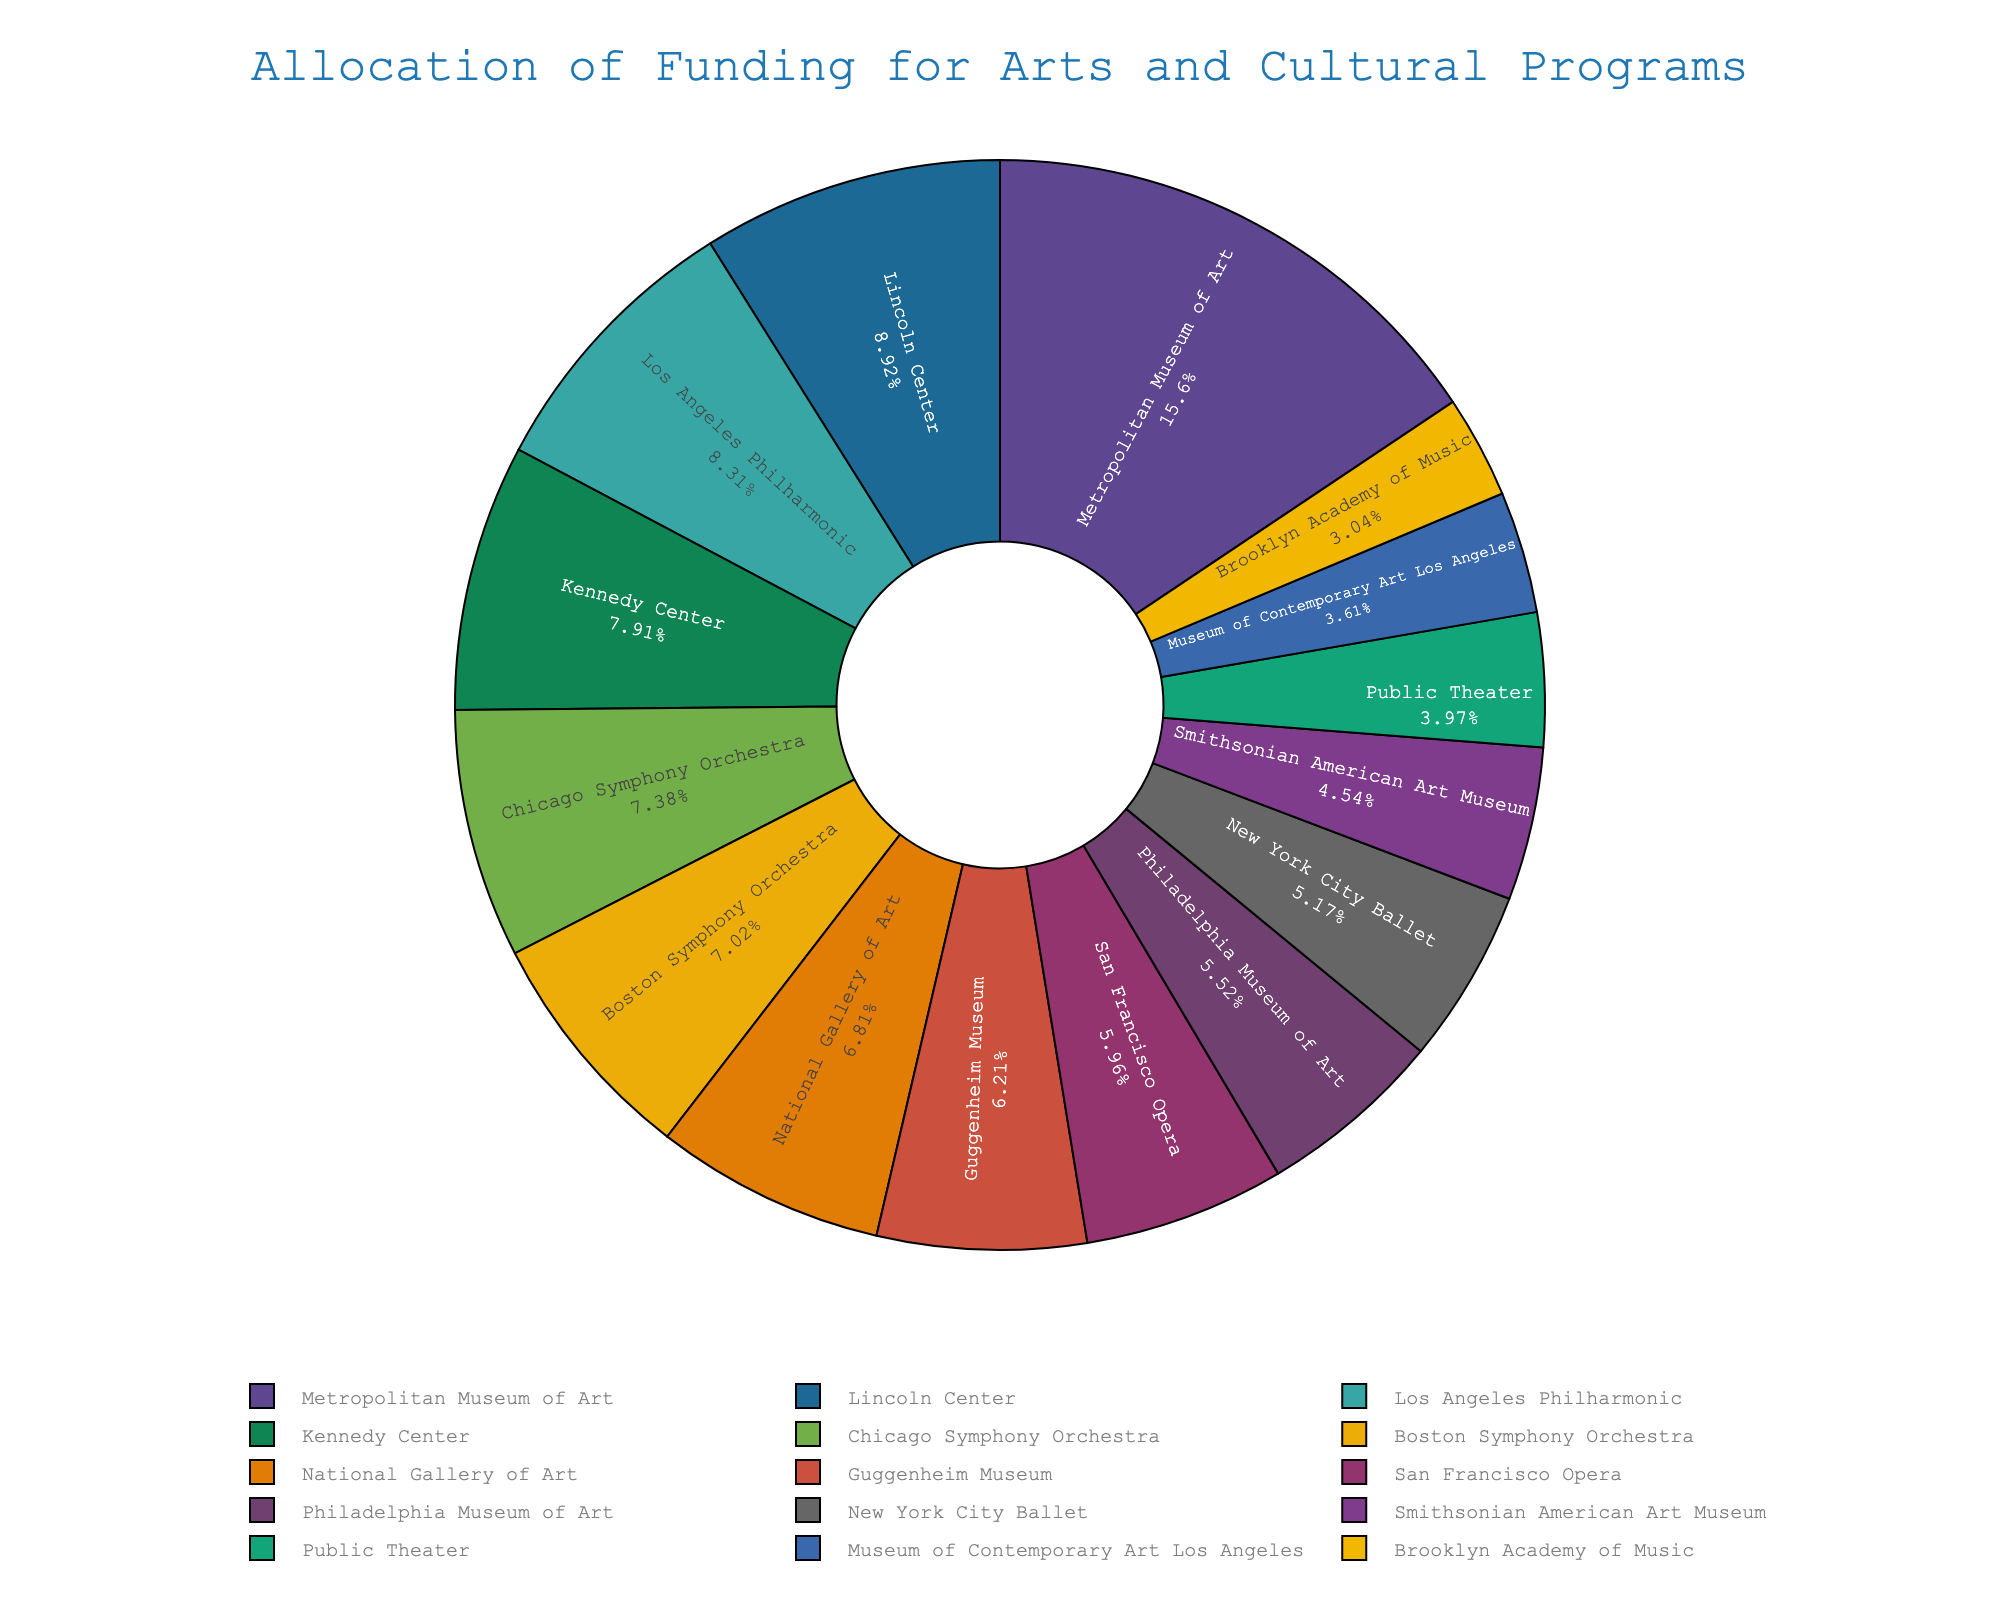Which program receives the largest funding allocation? Visually identify the program with the largest slice in the pie chart, which is positioned at the center top. Note the label associated with it.
Answer: Metropolitan Museum of Art Which program receives more funding: Kennedy Center or Smithsonian American Art Museum? Identify and compare the sizes of the slices corresponding to the Kennedy Center and the Smithsonian American Art Museum. The larger slice gets more funding.
Answer: Kennedy Center How much total funding is allocated to the Lincoln Center, New York City Ballet, and Public Theater combined? Sum the funding allocations for each program from the pie chart: 22,000,000 (Lincoln Center) + 12,750,000 (New York City Ballet) + 9,800,000 (Public Theater).
Answer: 44,550,000 Which program has the smallest funding allocation? Identify the smallest slice in the pie chart, which visually stands out as the least funding. Check the label for that slice.
Answer: Brooklyn Academy of Music Between the Boston Symphony Orchestra and the Los Angeles Philharmonic, which program has a higher funding allocation and by how much? Identify the slices for both programs and note their funding amounts. Subtract the lower amount from the higher one: 20,500,000 (Los Angeles Philharmonic) - 17,300,000 (Boston Symphony Orchestra).
Answer: Los Angeles Philharmonic by 3,200,000 What is the average funding allocation across all programs? Sum all individual funding allocations and divide by the number of programs. The total funding is 259,550,000. There are 15 programs, so the average is 259,550,000 / 15.
Answer: 17,303,333 Is the funding allocation for the Guggenheim Museum closer to the funding allocations for the Boston Symphony Orchestra or the National Gallery of Art? Identify the funding amounts for the Guggenheim Museum (15,300,000), Boston Symphony Orchestra (17,300,000), and National Gallery of Art (16,800,000). Calculate the absolute differences and compare:
Answer: National Gallery of Art Which programs receive a funding allocation greater than the average funding allocation? First, calculate the average funding allocation (as calculated previously: 17,303,333). Identify all programs with funding greater than this average from the pie chart.
Answer: Metropolitan Museum of Art, Lincoln Center, Los Angeles Philharmonic, Kennedy Center What is the total funding allocated to museums (Metropolitan Museum of Art, Guggenheim Museum, National Gallery of Art, Smithsonian American Art Museum, Philadelphia Museum of Art, and Museum of Contemporary Art Los Angeles)? Sum the funding allocations for the mentioned museums: 38,500,000 + 15,300,000 + 16,800,000 + 11,200,000 + 13,600,000 + 8,900,000.
Answer: 104,300,000 